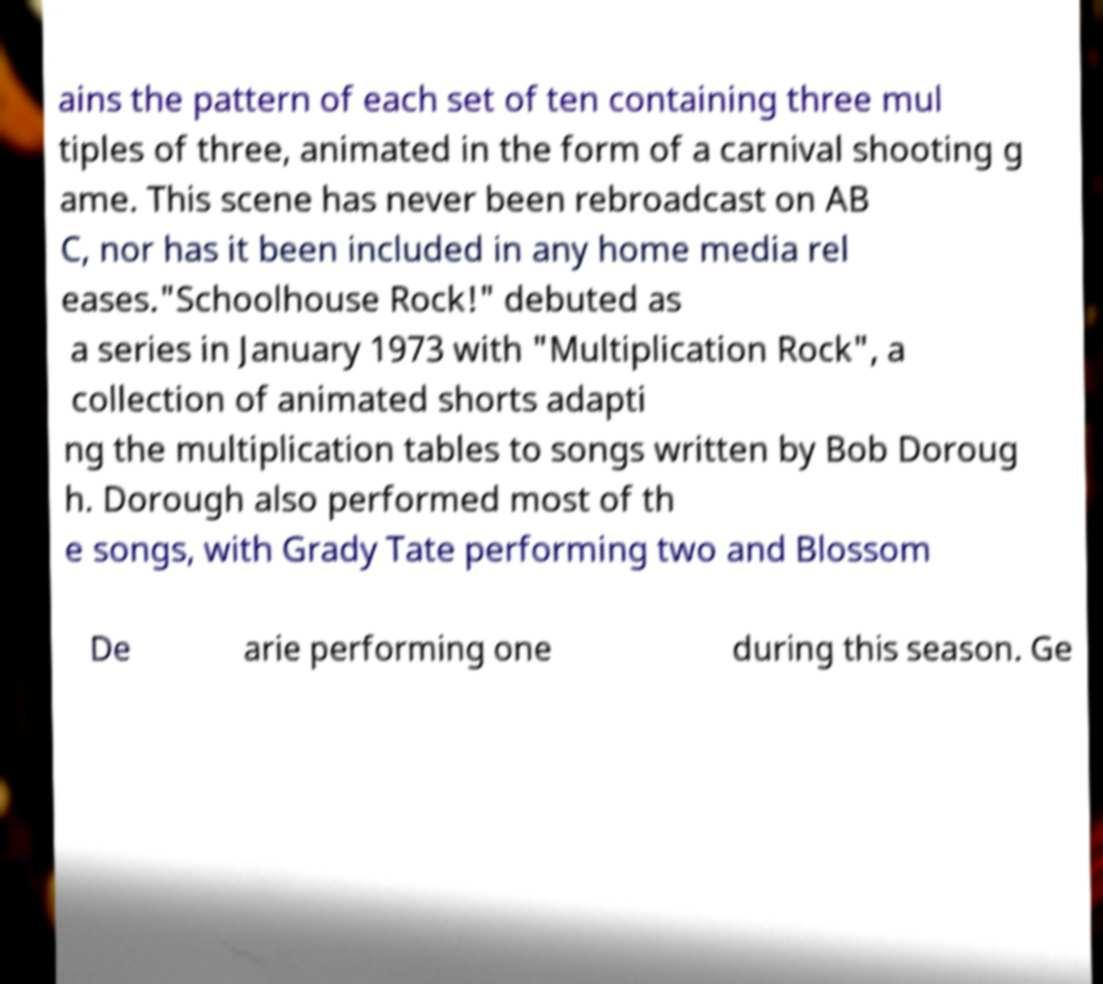Could you assist in decoding the text presented in this image and type it out clearly? ains the pattern of each set of ten containing three mul tiples of three, animated in the form of a carnival shooting g ame. This scene has never been rebroadcast on AB C, nor has it been included in any home media rel eases."Schoolhouse Rock!" debuted as a series in January 1973 with "Multiplication Rock", a collection of animated shorts adapti ng the multiplication tables to songs written by Bob Doroug h. Dorough also performed most of th e songs, with Grady Tate performing two and Blossom De arie performing one during this season. Ge 